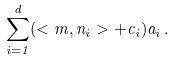Convert formula to latex. <formula><loc_0><loc_0><loc_500><loc_500>\sum _ { i = 1 } ^ { d } ( < m , n _ { i } > + c _ { i } ) a _ { i } \, .</formula> 